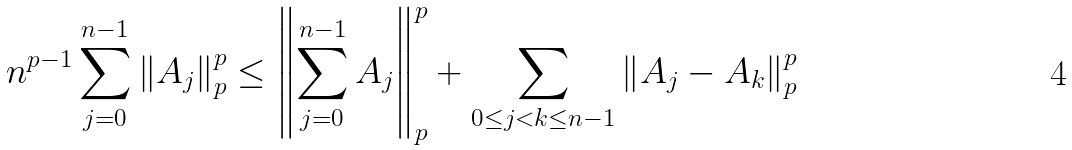<formula> <loc_0><loc_0><loc_500><loc_500>n ^ { p - 1 } \sum _ { j = 0 } ^ { n - 1 } \left \| A _ { j } \right \| _ { p } ^ { p } \leq \left \| \sum _ { j = 0 } ^ { n - 1 } A _ { j } \right \| _ { p } ^ { p } + \sum _ { 0 \leq j < k \leq n - 1 } \left \| A _ { j } - A _ { k } \right \| _ { p } ^ { p }</formula> 